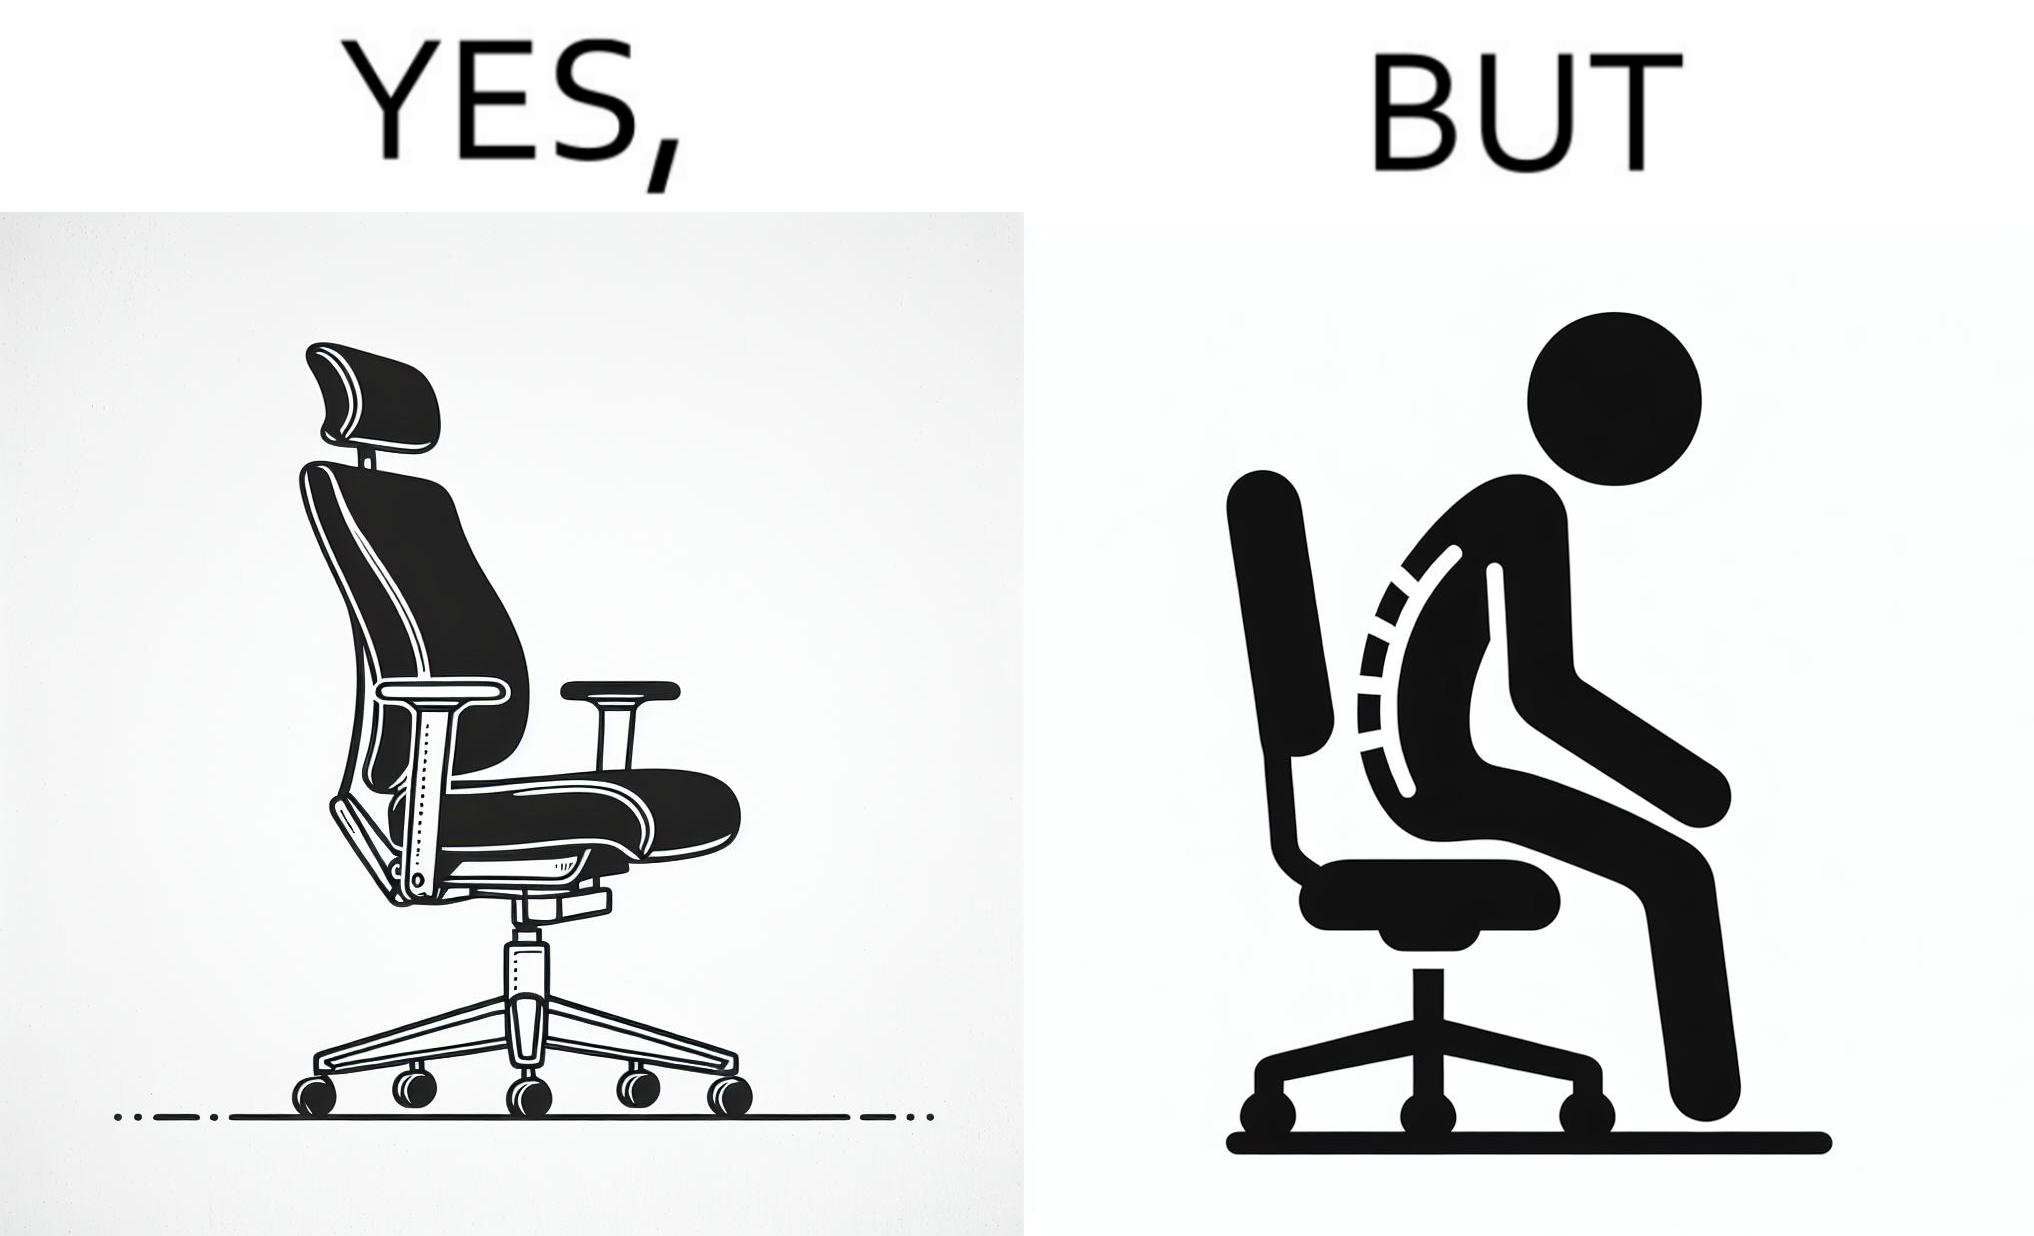Does this image contain satire or humor? Yes, this image is satirical. 